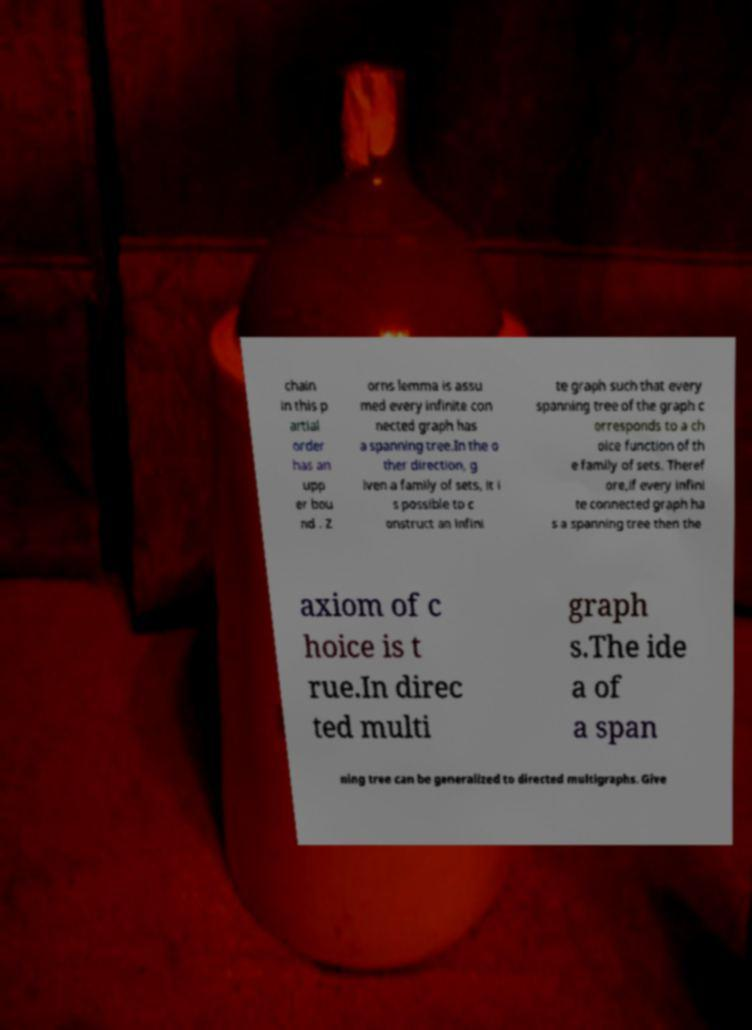Please identify and transcribe the text found in this image. chain in this p artial order has an upp er bou nd . Z orns lemma is assu med every infinite con nected graph has a spanning tree.In the o ther direction, g iven a family of sets, it i s possible to c onstruct an infini te graph such that every spanning tree of the graph c orresponds to a ch oice function of th e family of sets. Theref ore,if every infini te connected graph ha s a spanning tree then the axiom of c hoice is t rue.In direc ted multi graph s.The ide a of a span ning tree can be generalized to directed multigraphs. Give 